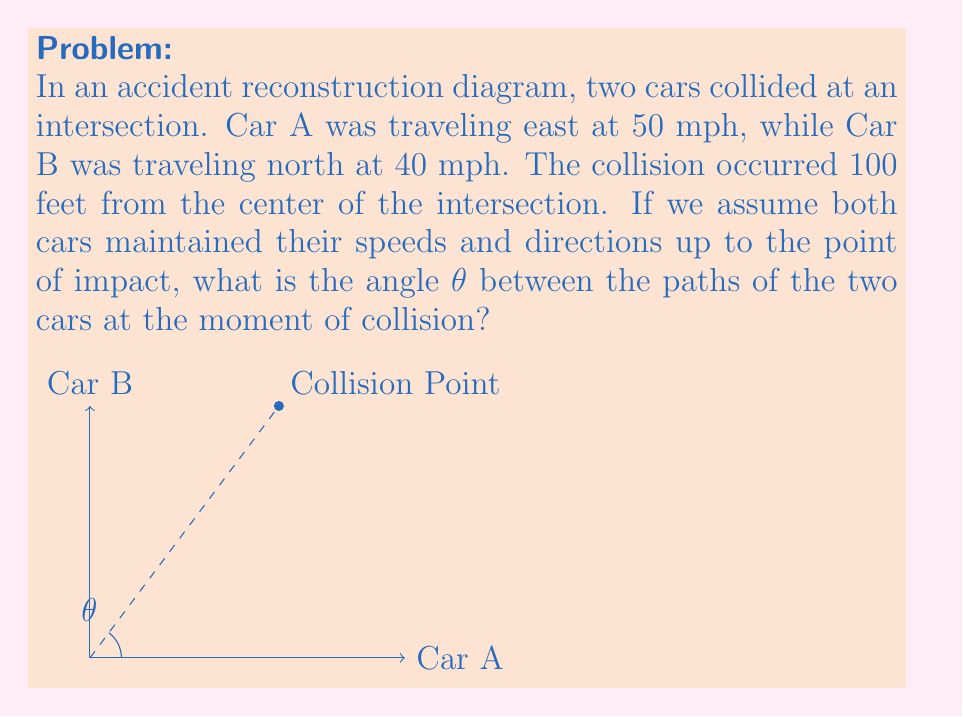Provide a solution to this math problem. To solve this problem, we'll use trigonometry and the concept of relative velocities. Let's break it down step-by-step:

1) First, we need to find the time it took for each car to reach the collision point. We can use the formula: $distance = speed * time$

   For Car A: $100 = 50 * t_A$, so $t_A = 2$ seconds
   For Car B: $100 = 40 * t_B$, so $t_B = 2.5$ seconds

2) Now, we can calculate the distances traveled by each car in 2 seconds (the time when Car A reaches the collision point):

   Car A: $50 * 2 = 100$ feet
   Car B: $40 * 2 = 80$ feet

3) We now have a right triangle where:
   - The hypotenuse is 100 feet (the distance to the collision point)
   - One side is 80 feet (the distance traveled by Car B)
   - The other side is 100 feet (the distance traveled by Car A)

4) We can use the arctangent function to find the angle θ:

   $$\theta = \arctan(\frac{80}{100})$$

5) Calculating this:

   $$\theta = \arctan(0.8) \approx 38.66°$$

Therefore, the angle between the paths of the two cars at the moment of collision is approximately 38.66°.
Answer: $38.66°$ 